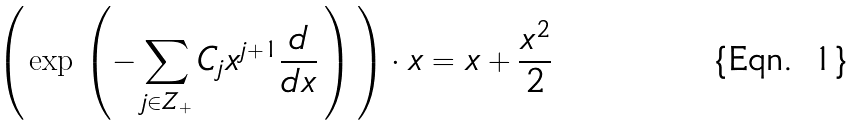Convert formula to latex. <formula><loc_0><loc_0><loc_500><loc_500>\left ( \, \exp \, \left ( - \sum _ { j \in Z _ { + } } C _ { j } x ^ { j + 1 } \frac { d } { d x } \, \right ) \, \right ) \cdot x = x + \frac { x ^ { 2 } } { 2 }</formula> 